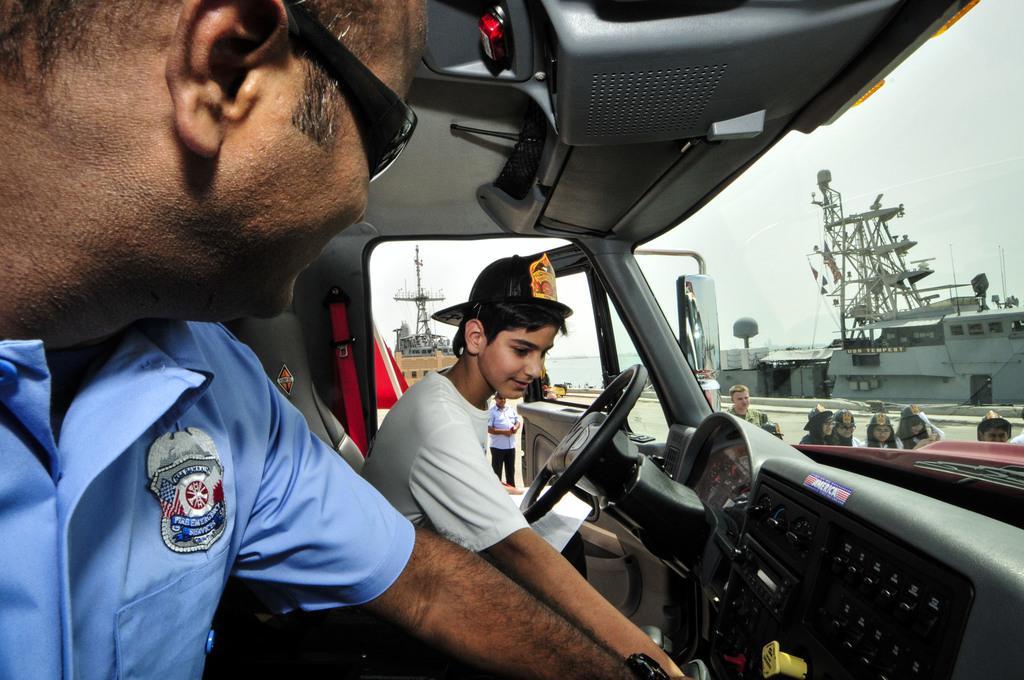How would you summarize this image in a sentence or two? In the foreground I can see two persons in a vehicle. In the background I can see a group of people are standing on the road, fence, ships in the water, ropes and the sky. This image is taken may be during a day may be near the ocean. 